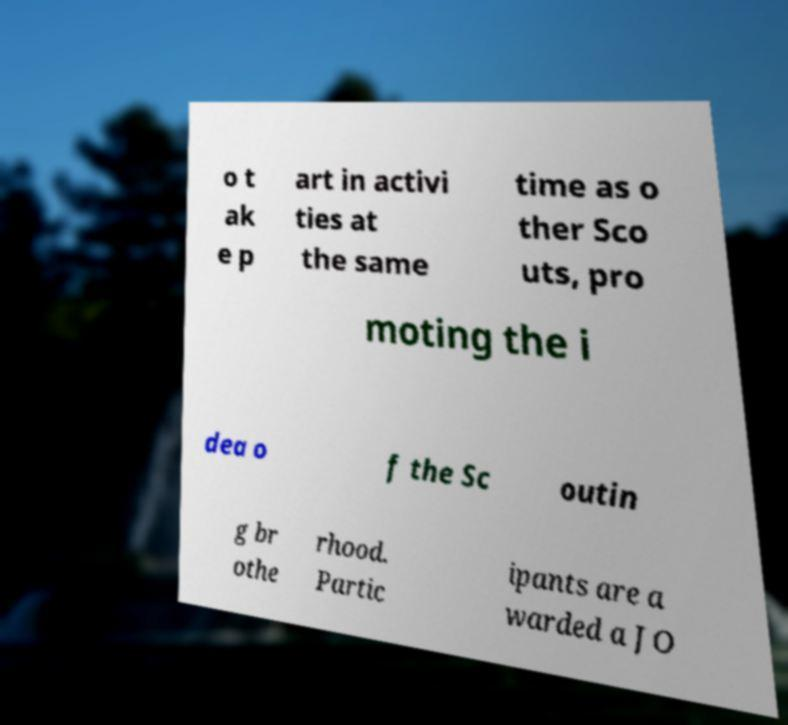Please identify and transcribe the text found in this image. o t ak e p art in activi ties at the same time as o ther Sco uts, pro moting the i dea o f the Sc outin g br othe rhood. Partic ipants are a warded a JO 